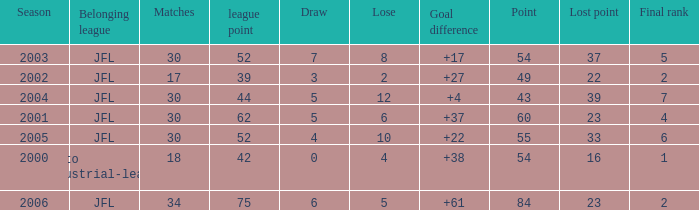Help me parse the entirety of this table. {'header': ['Season', 'Belonging league', 'Matches', 'league point', 'Draw', 'Lose', 'Goal difference', 'Point', 'Lost point', 'Final rank'], 'rows': [['2003', 'JFL', '30', '52', '7', '8', '+17', '54', '37', '5'], ['2002', 'JFL', '17', '39', '3', '2', '+27', '49', '22', '2'], ['2004', 'JFL', '30', '44', '5', '12', '+4', '43', '39', '7'], ['2001', 'JFL', '30', '62', '5', '6', '+37', '60', '23', '4'], ['2005', 'JFL', '30', '52', '4', '10', '+22', '55', '33', '6'], ['2000', 'Kanto industrial-league', '18', '42', '0', '4', '+38', '54', '16', '1'], ['2006', 'JFL', '34', '75', '6', '5', '+61', '84', '23', '2']]} Tell me the highest point with lost point being 33 and league point less than 52 None. 